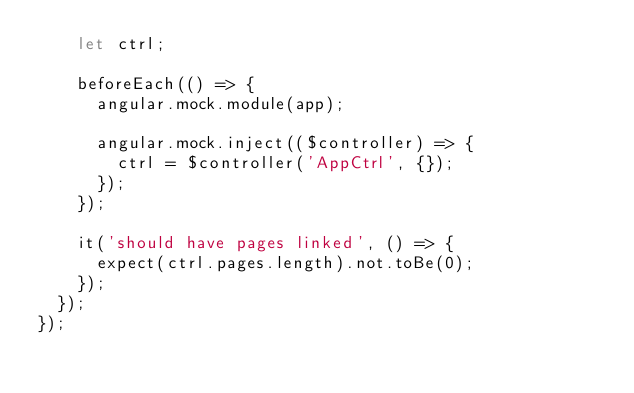Convert code to text. <code><loc_0><loc_0><loc_500><loc_500><_JavaScript_>    let ctrl;

    beforeEach(() => {
      angular.mock.module(app);

      angular.mock.inject(($controller) => {
        ctrl = $controller('AppCtrl', {});
      });
    });

    it('should have pages linked', () => {
      expect(ctrl.pages.length).not.toBe(0);
    });
  });
});</code> 